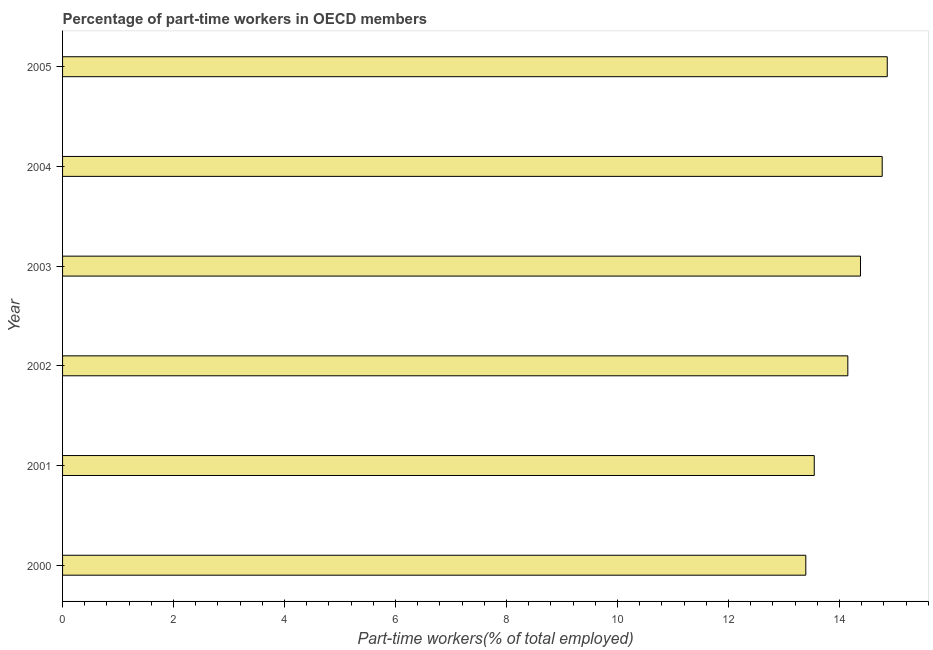Does the graph contain any zero values?
Keep it short and to the point. No. Does the graph contain grids?
Provide a short and direct response. No. What is the title of the graph?
Your response must be concise. Percentage of part-time workers in OECD members. What is the label or title of the X-axis?
Your answer should be compact. Part-time workers(% of total employed). What is the label or title of the Y-axis?
Offer a terse response. Year. What is the percentage of part-time workers in 2002?
Keep it short and to the point. 14.15. Across all years, what is the maximum percentage of part-time workers?
Ensure brevity in your answer.  14.86. Across all years, what is the minimum percentage of part-time workers?
Your answer should be compact. 13.39. In which year was the percentage of part-time workers maximum?
Provide a succinct answer. 2005. What is the sum of the percentage of part-time workers?
Make the answer very short. 85.09. What is the difference between the percentage of part-time workers in 2002 and 2005?
Make the answer very short. -0.71. What is the average percentage of part-time workers per year?
Offer a terse response. 14.18. What is the median percentage of part-time workers?
Your response must be concise. 14.26. In how many years, is the percentage of part-time workers greater than 9.6 %?
Your answer should be very brief. 6. What is the ratio of the percentage of part-time workers in 2002 to that in 2003?
Ensure brevity in your answer.  0.98. Is the percentage of part-time workers in 2004 less than that in 2005?
Provide a short and direct response. Yes. What is the difference between the highest and the second highest percentage of part-time workers?
Give a very brief answer. 0.09. What is the difference between the highest and the lowest percentage of part-time workers?
Give a very brief answer. 1.47. In how many years, is the percentage of part-time workers greater than the average percentage of part-time workers taken over all years?
Offer a very short reply. 3. How many bars are there?
Give a very brief answer. 6. Are all the bars in the graph horizontal?
Offer a very short reply. Yes. Are the values on the major ticks of X-axis written in scientific E-notation?
Provide a succinct answer. No. What is the Part-time workers(% of total employed) of 2000?
Provide a short and direct response. 13.39. What is the Part-time workers(% of total employed) in 2001?
Offer a terse response. 13.54. What is the Part-time workers(% of total employed) of 2002?
Your answer should be compact. 14.15. What is the Part-time workers(% of total employed) of 2003?
Offer a terse response. 14.38. What is the Part-time workers(% of total employed) of 2004?
Your answer should be very brief. 14.77. What is the Part-time workers(% of total employed) in 2005?
Offer a terse response. 14.86. What is the difference between the Part-time workers(% of total employed) in 2000 and 2001?
Your answer should be compact. -0.15. What is the difference between the Part-time workers(% of total employed) in 2000 and 2002?
Provide a succinct answer. -0.76. What is the difference between the Part-time workers(% of total employed) in 2000 and 2003?
Offer a very short reply. -0.99. What is the difference between the Part-time workers(% of total employed) in 2000 and 2004?
Make the answer very short. -1.38. What is the difference between the Part-time workers(% of total employed) in 2000 and 2005?
Give a very brief answer. -1.47. What is the difference between the Part-time workers(% of total employed) in 2001 and 2002?
Offer a terse response. -0.61. What is the difference between the Part-time workers(% of total employed) in 2001 and 2003?
Your answer should be very brief. -0.83. What is the difference between the Part-time workers(% of total employed) in 2001 and 2004?
Provide a short and direct response. -1.22. What is the difference between the Part-time workers(% of total employed) in 2001 and 2005?
Offer a terse response. -1.32. What is the difference between the Part-time workers(% of total employed) in 2002 and 2003?
Provide a succinct answer. -0.23. What is the difference between the Part-time workers(% of total employed) in 2002 and 2004?
Your response must be concise. -0.62. What is the difference between the Part-time workers(% of total employed) in 2002 and 2005?
Keep it short and to the point. -0.71. What is the difference between the Part-time workers(% of total employed) in 2003 and 2004?
Provide a succinct answer. -0.39. What is the difference between the Part-time workers(% of total employed) in 2003 and 2005?
Your answer should be compact. -0.48. What is the difference between the Part-time workers(% of total employed) in 2004 and 2005?
Your answer should be compact. -0.09. What is the ratio of the Part-time workers(% of total employed) in 2000 to that in 2001?
Offer a very short reply. 0.99. What is the ratio of the Part-time workers(% of total employed) in 2000 to that in 2002?
Keep it short and to the point. 0.95. What is the ratio of the Part-time workers(% of total employed) in 2000 to that in 2004?
Offer a very short reply. 0.91. What is the ratio of the Part-time workers(% of total employed) in 2000 to that in 2005?
Keep it short and to the point. 0.9. What is the ratio of the Part-time workers(% of total employed) in 2001 to that in 2002?
Your answer should be compact. 0.96. What is the ratio of the Part-time workers(% of total employed) in 2001 to that in 2003?
Your answer should be compact. 0.94. What is the ratio of the Part-time workers(% of total employed) in 2001 to that in 2004?
Give a very brief answer. 0.92. What is the ratio of the Part-time workers(% of total employed) in 2001 to that in 2005?
Provide a short and direct response. 0.91. What is the ratio of the Part-time workers(% of total employed) in 2002 to that in 2003?
Your answer should be very brief. 0.98. What is the ratio of the Part-time workers(% of total employed) in 2002 to that in 2004?
Keep it short and to the point. 0.96. What is the ratio of the Part-time workers(% of total employed) in 2002 to that in 2005?
Give a very brief answer. 0.95. 